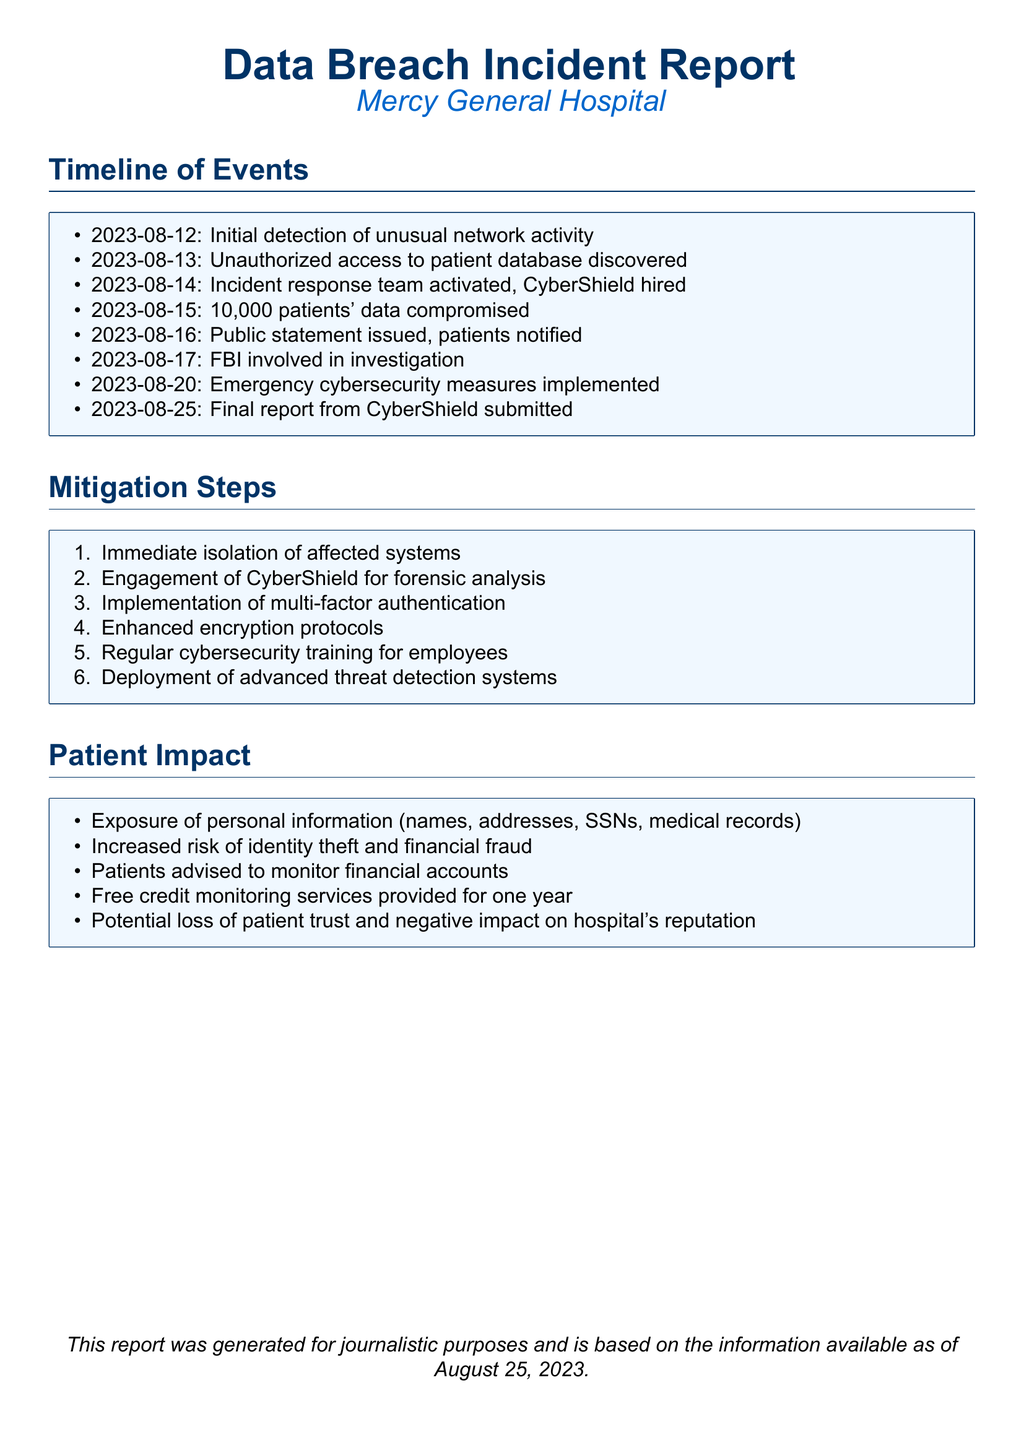What date was the unauthorized access discovered? The unauthorized access was discovered on August 13, 2023, which is stated directly in the timeline of events.
Answer: August 13, 2023 How many patients' data were compromised? The document states that 10,000 patients' data were compromised on August 15, 2023.
Answer: 10,000 What company was hired for the forensic analysis? The incident report mentions that CyberShield was engaged for forensic analysis on August 14, 2023.
Answer: CyberShield What kind of authentication was implemented? The document states that multi-factor authentication was one of the mitigation steps taken after the breach.
Answer: Multi-factor authentication What is one of the impacts on patients mentioned in the report? The report lists several impacts, including the increased risk of identity theft, which is a significant concern for patients.
Answer: Increased risk of identity theft Why did the hospital issue a public statement? The public statement was issued to notify patients about the unauthorized access to their data, informing them of the breach's seriousness and potential impact.
Answer: To notify patients On what date was the final report submitted by CyberShield? According to the timeline, the final report from CyberShield was submitted on August 25, 2023.
Answer: August 25, 2023 What training was implemented for employees? The report includes regular cybersecurity training as one of the mitigation steps taken after the breach.
Answer: Regular cybersecurity training What is provided to patients for a year? The document mentions that free credit monitoring services were provided to patients for one year following the breach.
Answer: Free credit monitoring services 